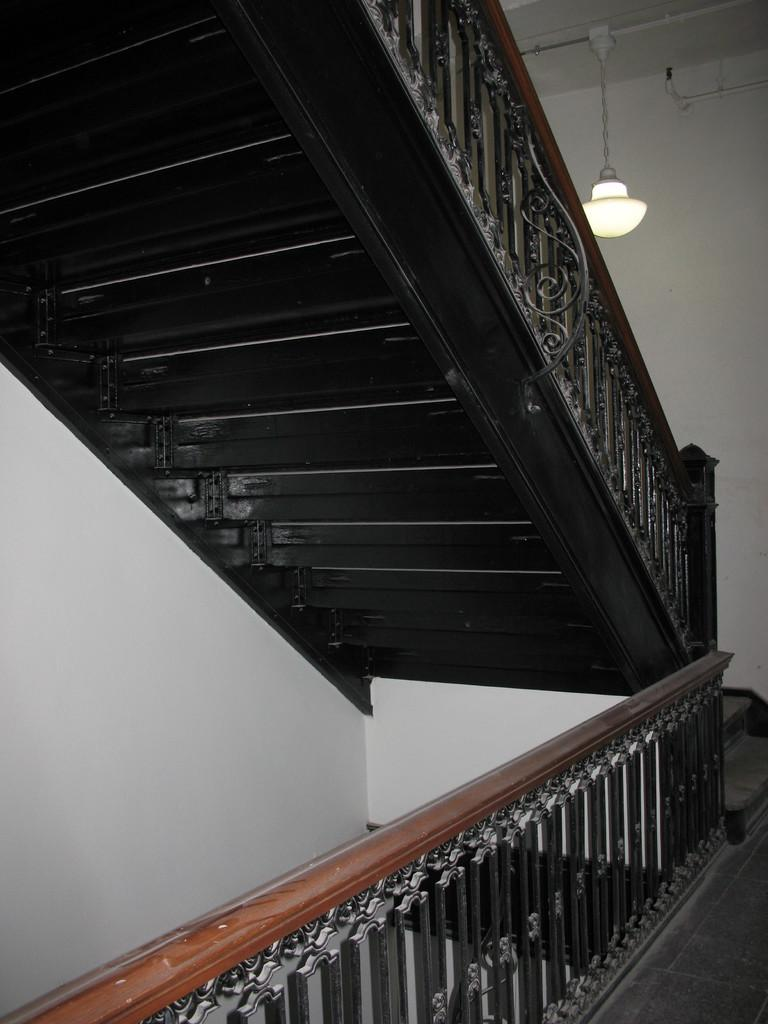What type of structure is present in the image? There are stairs in the image. What feature is associated with the stairs? There is a metal railing associated with the stairs. What can be seen providing illumination in the image? There are lights visible in the image. What type of architectural element is present in the image? There is a wall in the image. What type of cart is being pushed by the thought in the image? There is no cart or thought present in the image; it only features stairs, a metal railing, lights, and a wall. 